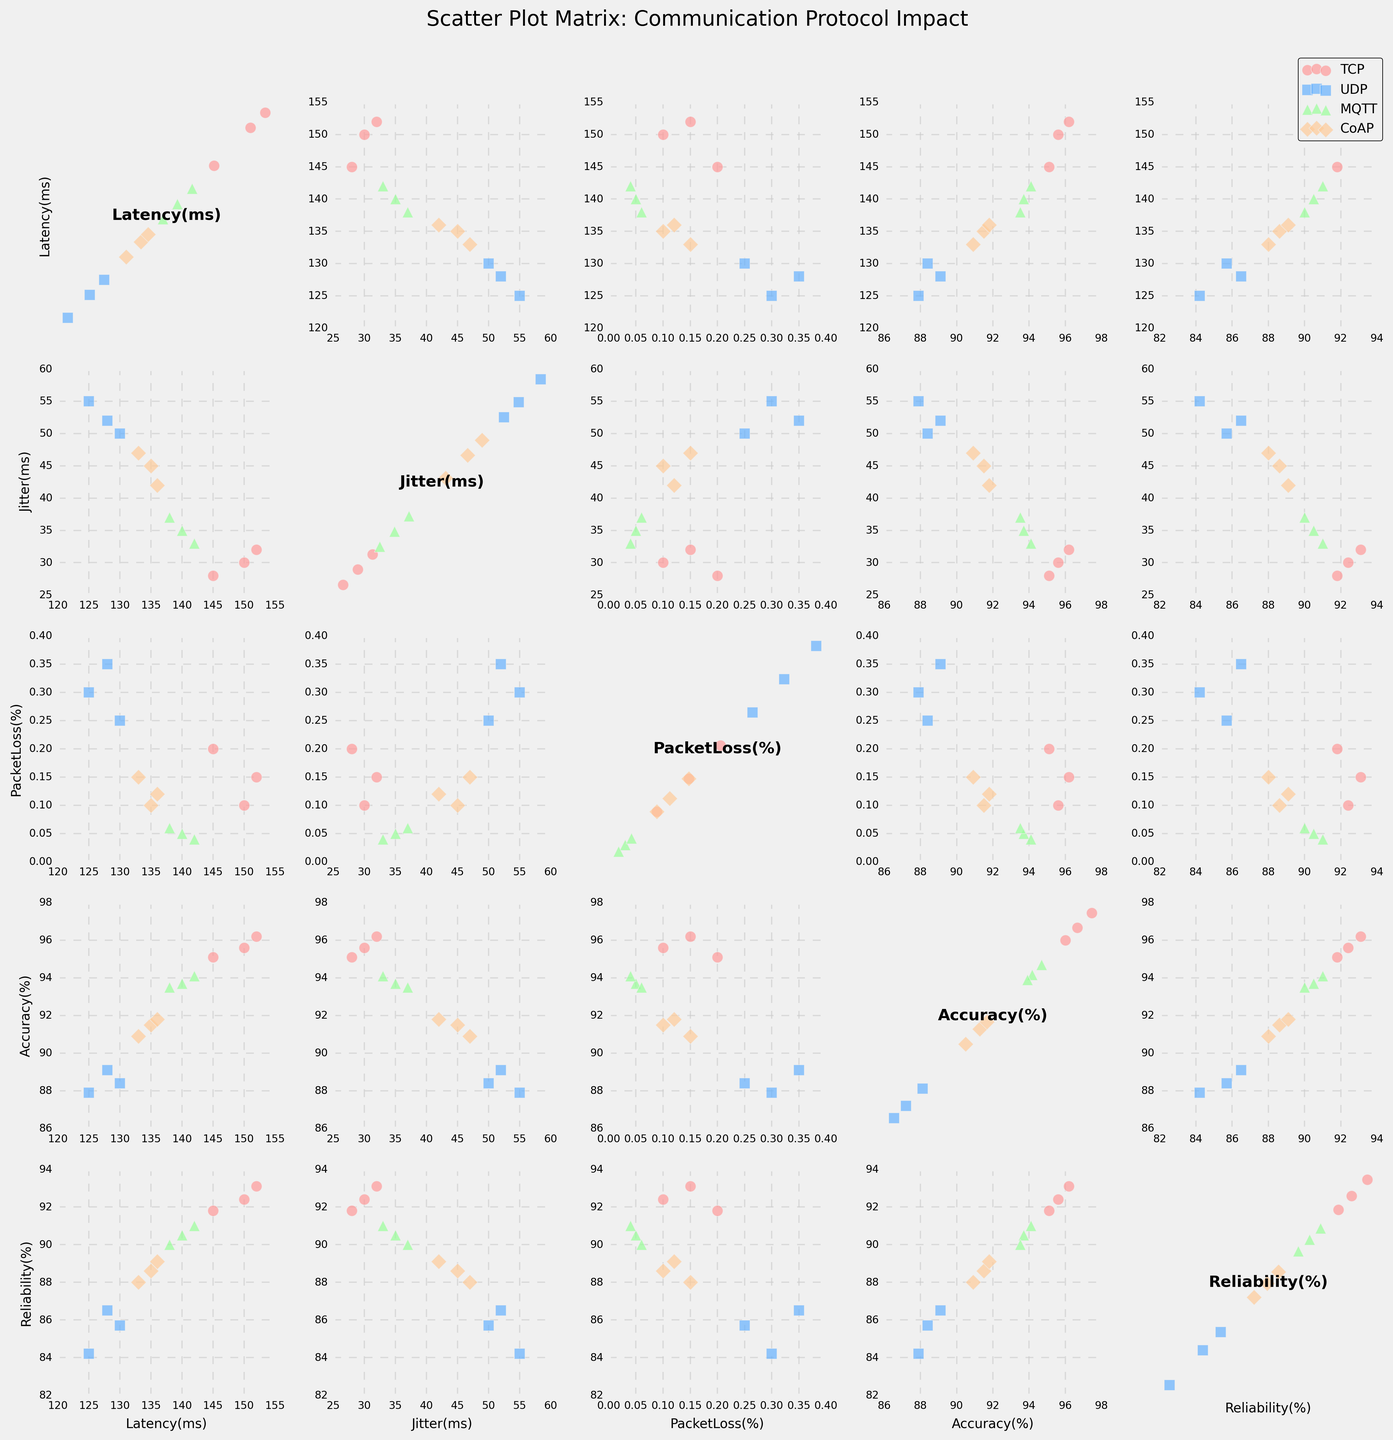What are the axes labeled in the SPLOM? Each plot in the SPLOM has axes labeled with the different numeric variables. The x-axis and y-axis labels vary across plots, but they include 'Latency(ms)', 'Jitter(ms)', 'PacketLoss(%)', 'Accuracy(%)', and 'Reliability(%)'.
Answer: 'Latency(ms)', 'Jitter(ms)', 'PacketLoss(%)', 'Accuracy(%)', 'Reliability(%)' How many data points are plotted for each protocol? For each protocol, focus on how many points are plotted per combination of variables shown in the scatter plots. There are 3 data points for TCP, 3 for UDP, 3 for MQTT, and 3 for CoAP.
Answer: 3 for each protocol Which protocol shows the highest accuracy in the SPLOM? Look at the plots where 'Accuracy(%)' is the y-axis variable. The highest accuracy value is close to 96.2, which corresponds to the TCP protocol.
Answer: TCP Are there any apparent correlations between 'Latency(ms)' and 'Accuracy(%)' for the different protocols? To assess this, observe the subplots where 'Latency(ms)' is on one axis and 'Accuracy(%)' is on the other. For TCP, higher latency tends to correspond with higher accuracy, whereas for other protocols like UDP, the accuracy remains relatively low for all latencies.
Answer: Positive for TCP, not clear for others Which protocol demonstrates the most variability in 'Jitter(ms)'? In the subplots where 'Jitter(ms)' is plotted, examine the spread of data points along the x-axis or the y-axis. UDP exhibits the highest range in jitter values, from 50 to 55.
Answer: UDP How does 'PacketLoss(%)' affect 'Reliability(%)' across different protocols? Look at the subplots where 'PacketLoss(%)' is the x-axis and 'Reliability(%)' is the y-axis. You can see that TCP and MQTT maintain higher reliability even when packet loss varies slightly, unlike UDP and CoAP, where higher packet loss corresponds to lower reliability.
Answer: TCP and MQTT maintain higher reliability; UDP and CoAP do not Does 'Latency(ms)' tend to be higher for any specific protocol? Examine the subplots for 'Latency(ms)'. TCP tends to have the highest latency values, spanning from about 145 to 152 ms.
Answer: TCP Compare 'Reliability(%)' for UDP and CoAP protocols. Which one has the higher average reliability? Focus on subplots with 'Reliability(%)' and compare UDP and CoAP data points. CoAP generally has higher reliability values, averaging around 88.6%, compared to UDP's average around 85.5%.
Answer: CoAP Is there any clear relationship between 'Accuracy(%)' and 'Reliability(%)' for the protocols? Review the subplots where 'Accuracy(%)' is on one axis and 'Reliability(%)' is on the other. Generally, higher accuracy tends to correspond to higher reliability across all protocols, especially pronounced in TCP and MQTT.
Answer: Yes, positive correlation for all protocols Which protocol has the most consistent (least variable) 'PacketLoss(%)' values? In the subplots including 'PacketLoss(%)', identify the protocol with the least spread in values. MQTT exhibits very low and consistent packet loss values around 0.04 to 0.06%.
Answer: MQTT 